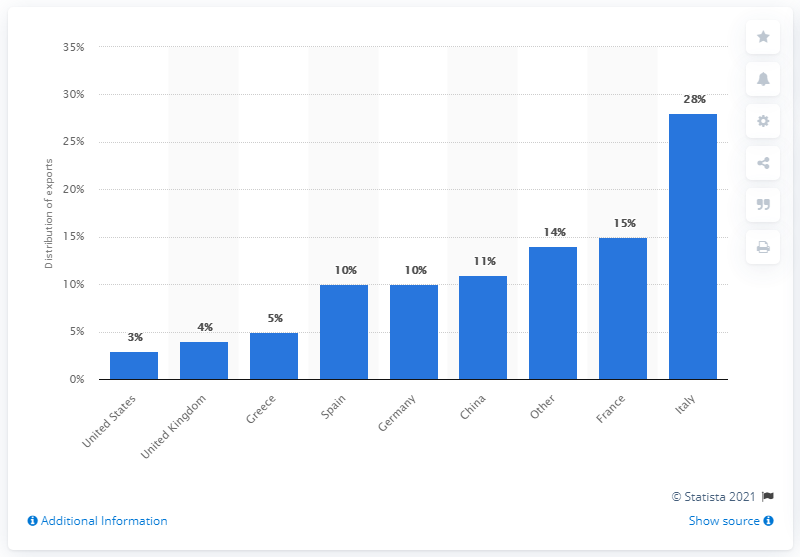Highlight a few significant elements in this photo. In 2010, China received 11% of Libya's total oil exports. 